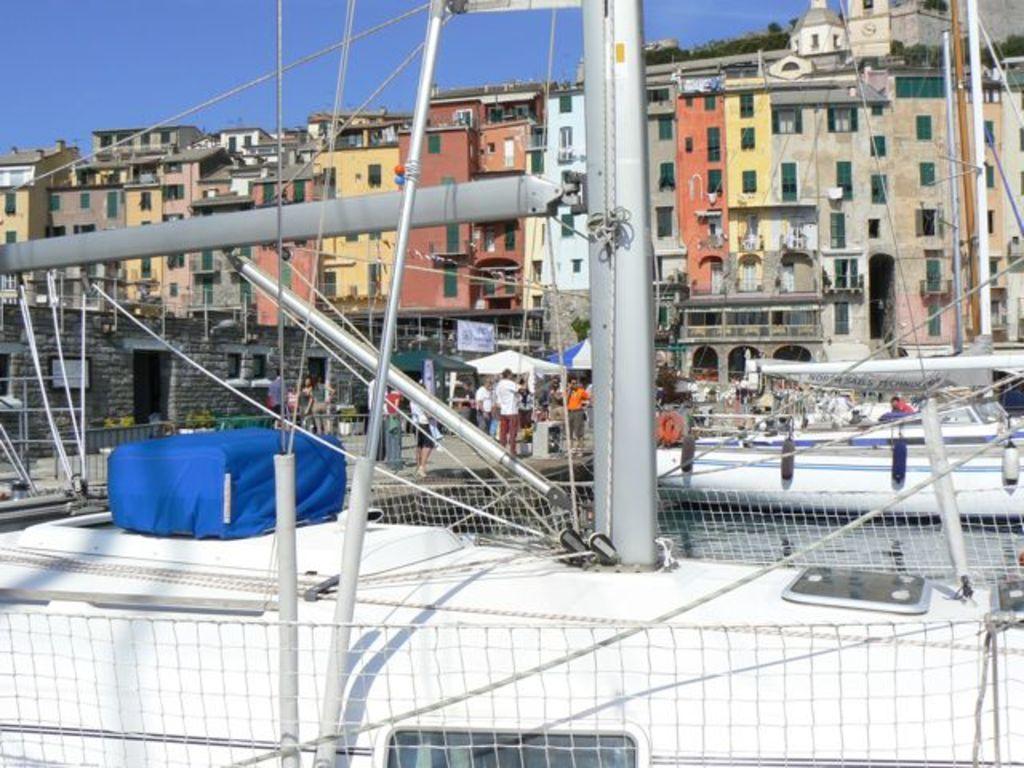Please provide a concise description of this image. In the image there are rods, wires and many other objects in the foreground and behind the the rods there are few people, tents and in the background there are buildings. 